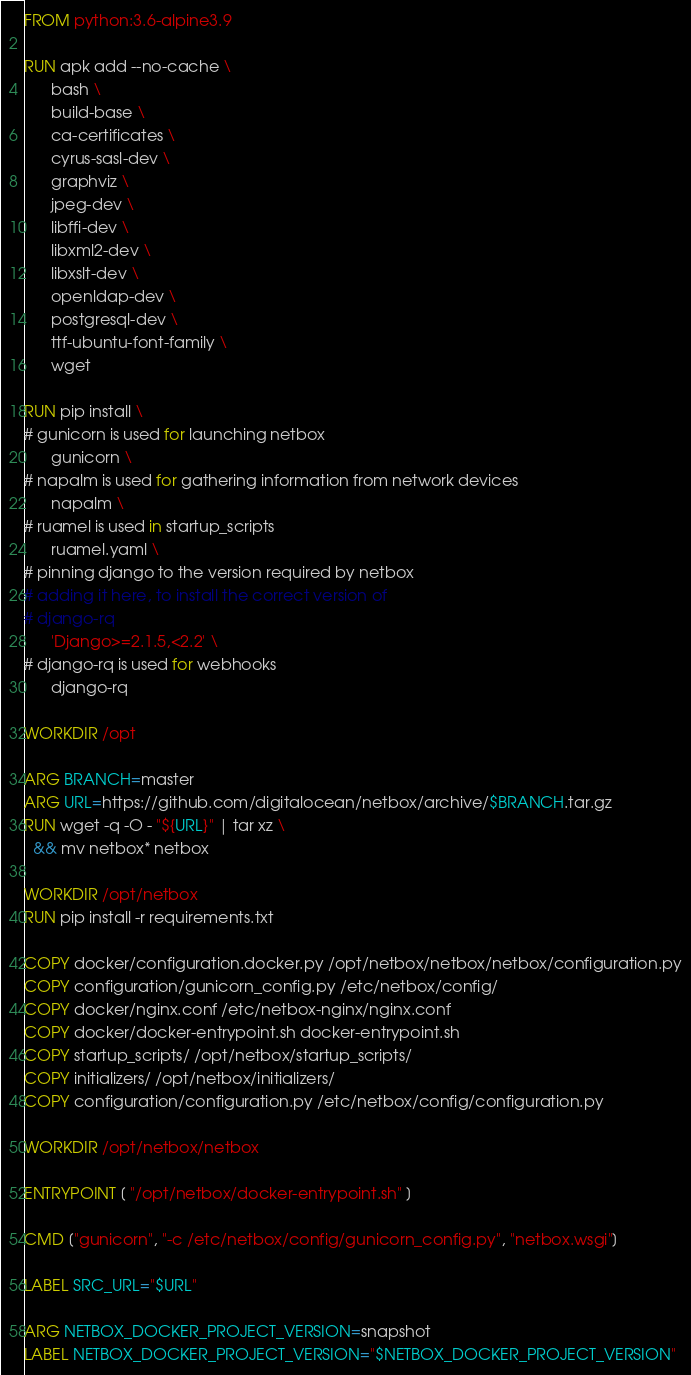<code> <loc_0><loc_0><loc_500><loc_500><_Dockerfile_>FROM python:3.6-alpine3.9

RUN apk add --no-cache \
      bash \
      build-base \
      ca-certificates \
      cyrus-sasl-dev \
      graphviz \
      jpeg-dev \
      libffi-dev \
      libxml2-dev \
      libxslt-dev \
      openldap-dev \
      postgresql-dev \
      ttf-ubuntu-font-family \
      wget

RUN pip install \
# gunicorn is used for launching netbox
      gunicorn \
# napalm is used for gathering information from network devices
      napalm \
# ruamel is used in startup_scripts
      ruamel.yaml \
# pinning django to the version required by netbox
# adding it here, to install the correct version of
# django-rq
      'Django>=2.1.5,<2.2' \
# django-rq is used for webhooks
      django-rq

WORKDIR /opt

ARG BRANCH=master
ARG URL=https://github.com/digitalocean/netbox/archive/$BRANCH.tar.gz
RUN wget -q -O - "${URL}" | tar xz \
  && mv netbox* netbox

WORKDIR /opt/netbox
RUN pip install -r requirements.txt

COPY docker/configuration.docker.py /opt/netbox/netbox/netbox/configuration.py
COPY configuration/gunicorn_config.py /etc/netbox/config/
COPY docker/nginx.conf /etc/netbox-nginx/nginx.conf
COPY docker/docker-entrypoint.sh docker-entrypoint.sh
COPY startup_scripts/ /opt/netbox/startup_scripts/
COPY initializers/ /opt/netbox/initializers/
COPY configuration/configuration.py /etc/netbox/config/configuration.py

WORKDIR /opt/netbox/netbox

ENTRYPOINT [ "/opt/netbox/docker-entrypoint.sh" ]

CMD ["gunicorn", "-c /etc/netbox/config/gunicorn_config.py", "netbox.wsgi"]

LABEL SRC_URL="$URL"

ARG NETBOX_DOCKER_PROJECT_VERSION=snapshot
LABEL NETBOX_DOCKER_PROJECT_VERSION="$NETBOX_DOCKER_PROJECT_VERSION"
</code> 